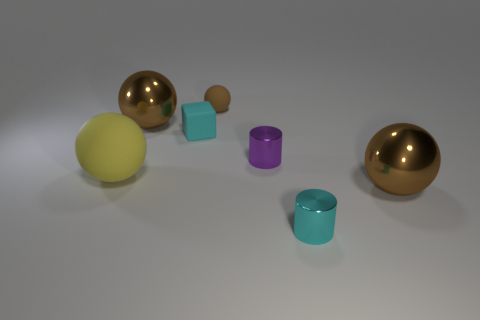Is there anything else that has the same shape as the tiny cyan rubber object?
Ensure brevity in your answer.  No. What number of other objects are the same shape as the yellow thing?
Offer a terse response. 3. Is the size of the purple metallic cylinder the same as the yellow object?
Make the answer very short. No. Are any tiny shiny spheres visible?
Offer a very short reply. No. Are there any big brown things made of the same material as the tiny cyan cylinder?
Offer a terse response. Yes. There is a sphere that is the same size as the rubber cube; what material is it?
Give a very brief answer. Rubber. What number of other things are the same shape as the tiny brown object?
Give a very brief answer. 3. There is a purple object that is the same material as the cyan cylinder; what size is it?
Provide a short and direct response. Small. The sphere that is on the right side of the tiny rubber cube and to the left of the cyan metal object is made of what material?
Provide a succinct answer. Rubber. How many other metallic blocks have the same size as the cyan block?
Provide a short and direct response. 0. 